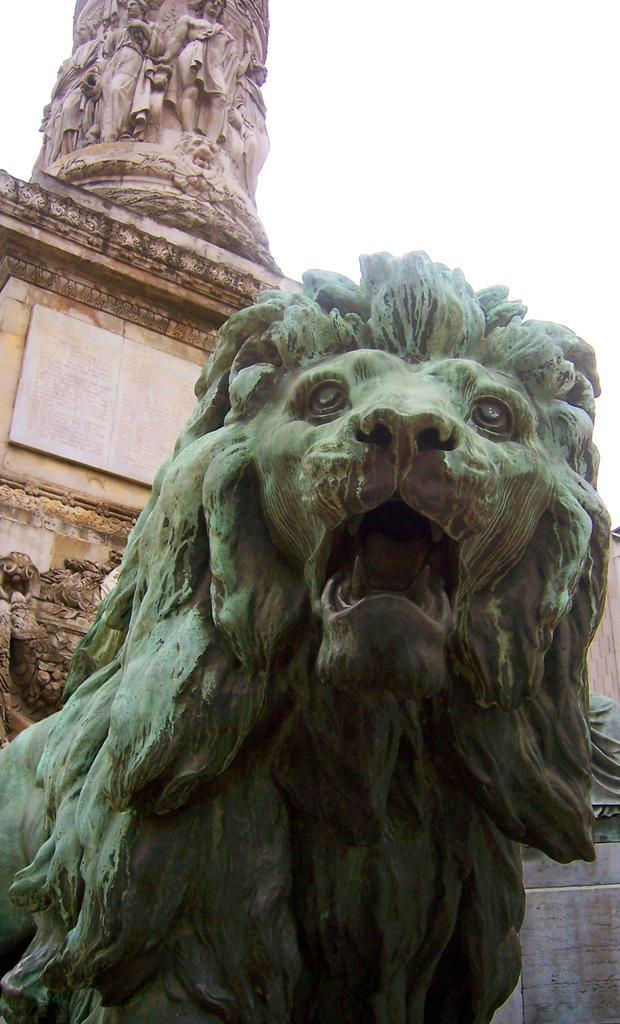How would you summarize this image in a sentence or two? Here in this picture we can see a statue of a lion present over there and behind that we can see other statues present on the wall over there. 